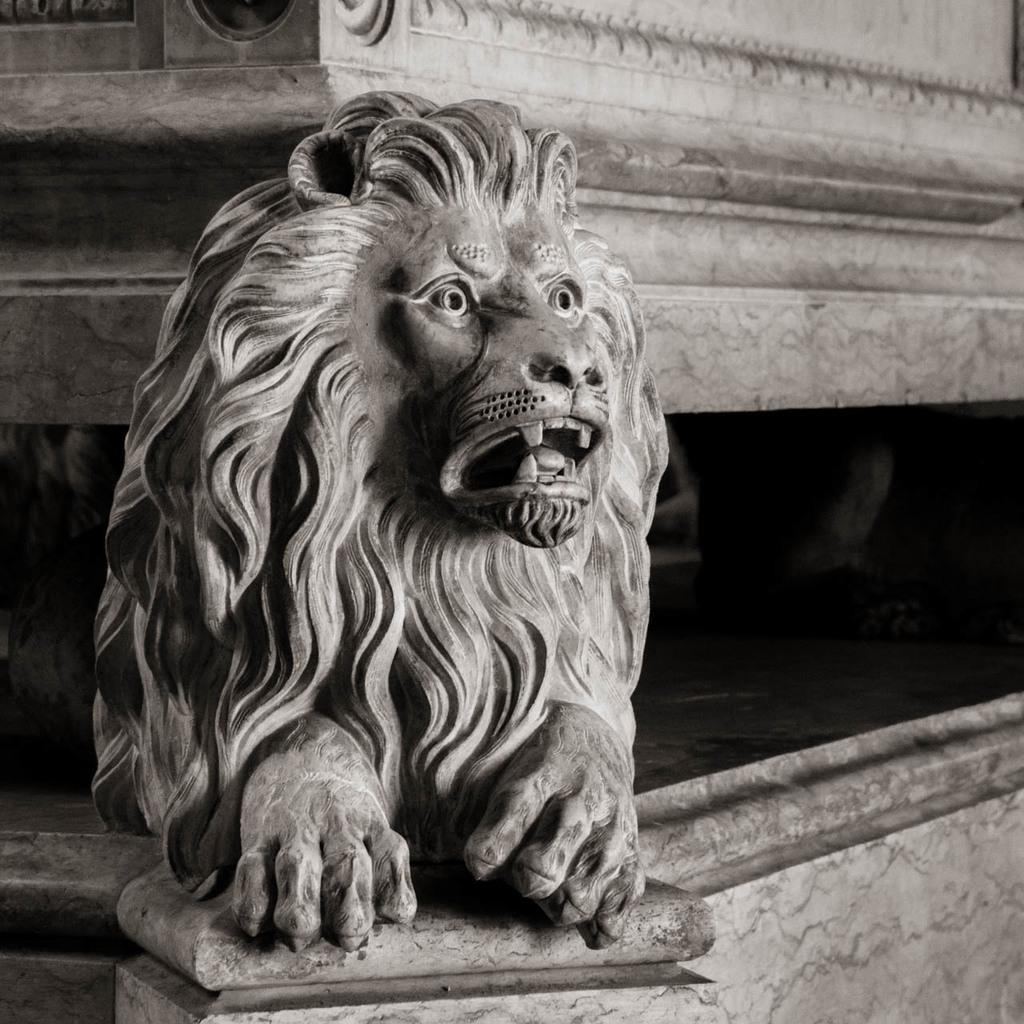What is the color scheme of the image? The image is black and white. What can be seen in the image that resembles a living creature? There is a statue of an animal in the image. What type of structure is present in the image? There is a wall in the image. What type of design can be seen on the thrill-inducing apparatus in the image? There is no thrill-inducing apparatus present in the image; it features a statue of an animal and a wall. 